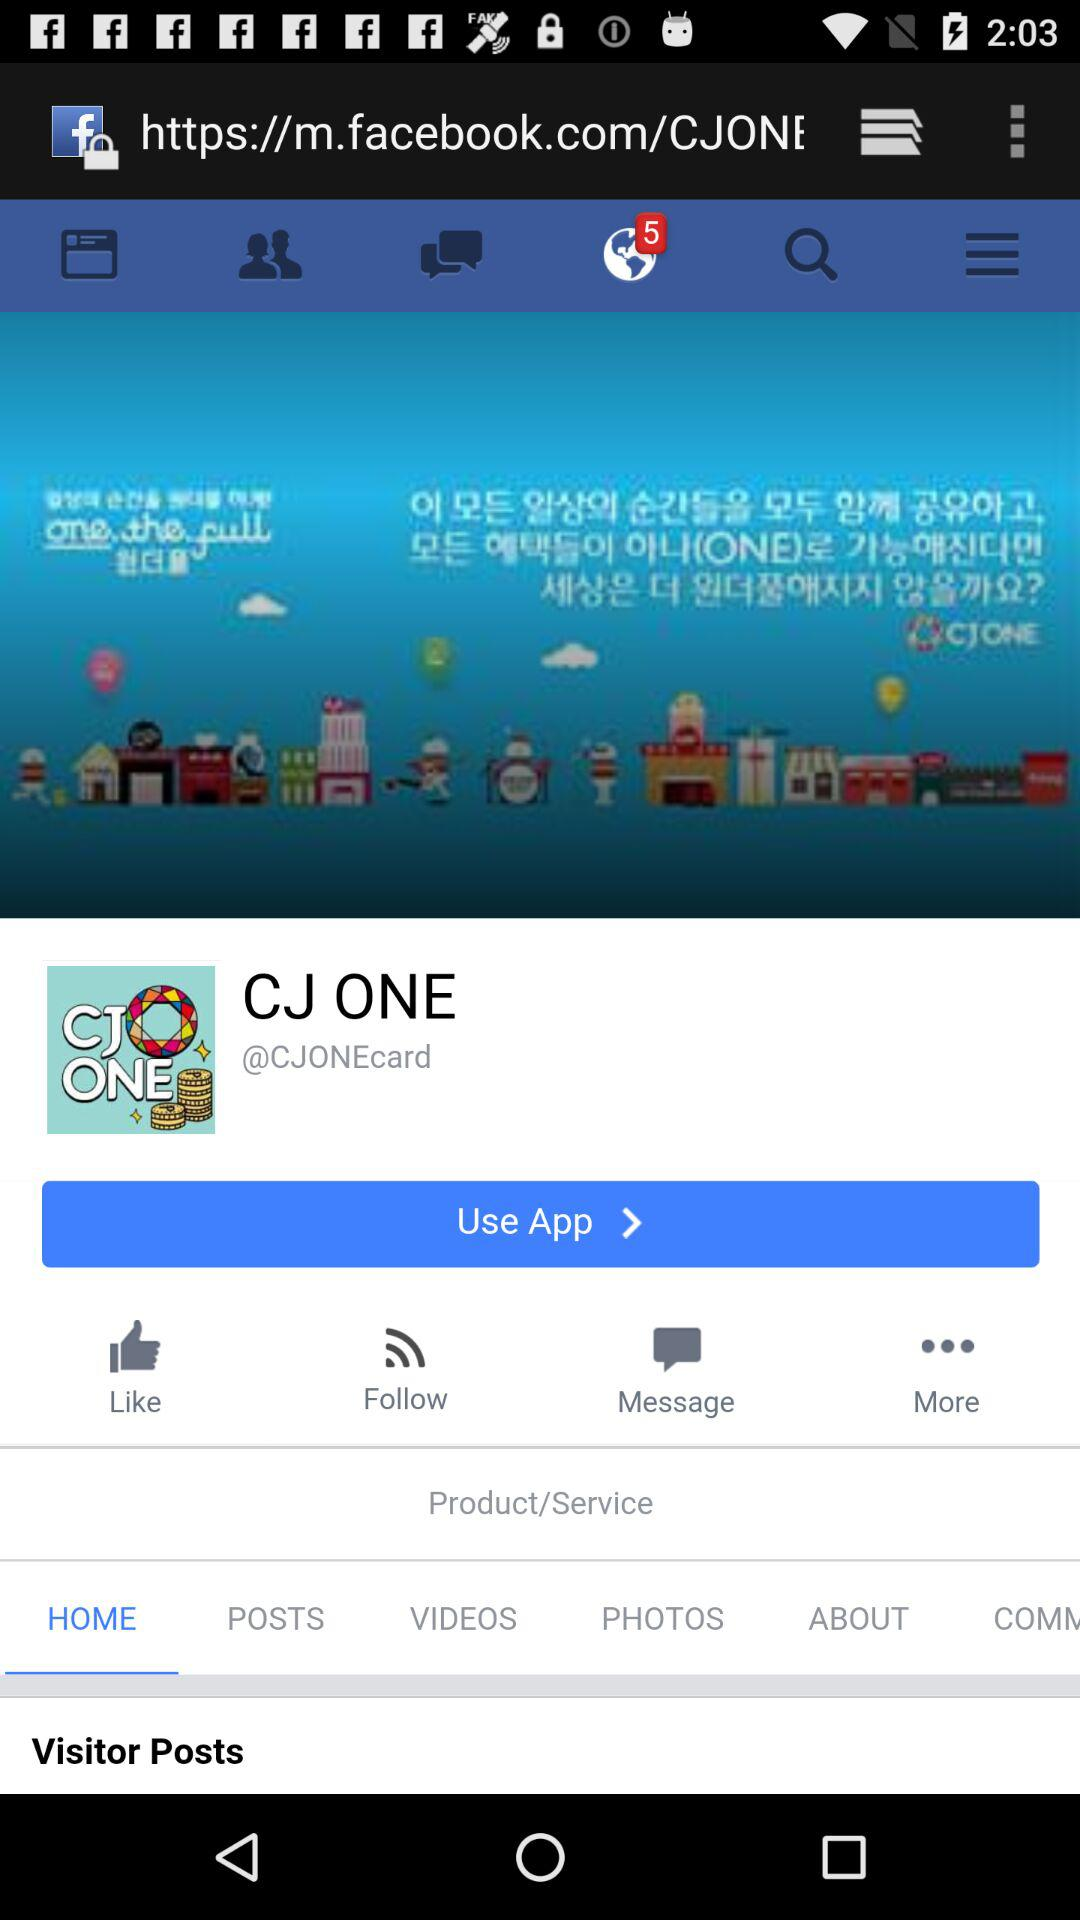How many unread notifications are shown on the screen? There are 5 unread notifications shown on the screen. 